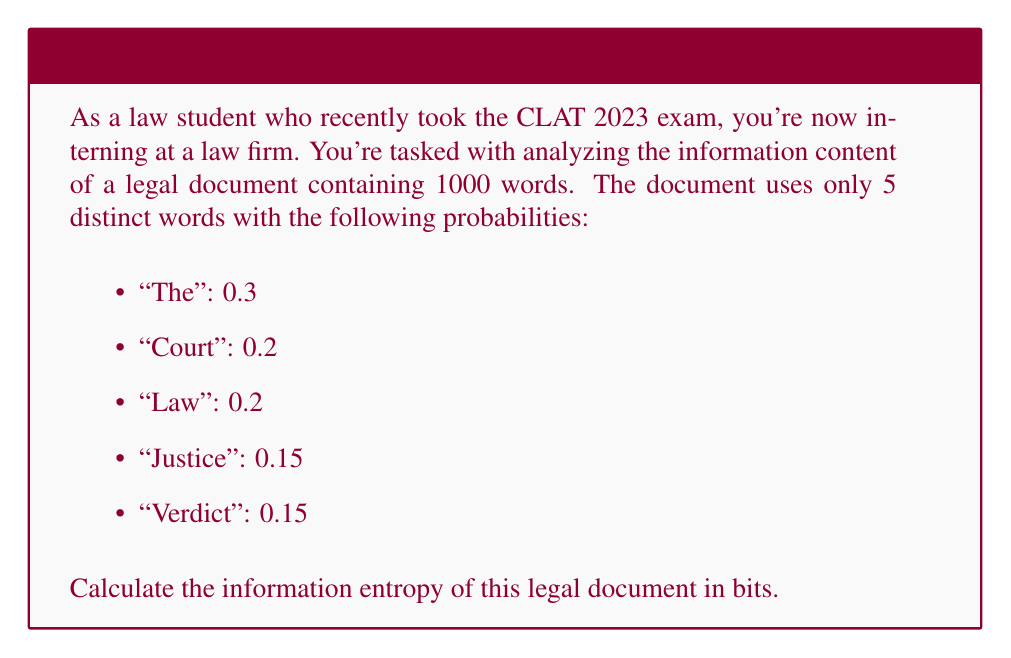Help me with this question. To solve this problem, we'll use the formula for information entropy:

$$ H = -\sum_{i=1}^n p_i \log_2(p_i) $$

Where:
- $H$ is the information entropy
- $p_i$ is the probability of each word
- $n$ is the number of distinct words

Let's calculate the entropy for each word:

1. "The": $-0.3 \log_2(0.3) = 0.521$ bits
2. "Court": $-0.2 \log_2(0.2) = 0.464$ bits
3. "Law": $-0.2 \log_2(0.2) = 0.464$ bits
4. "Justice": $-0.15 \log_2(0.15) = 0.411$ bits
5. "Verdict": $-0.15 \log_2(0.15) = 0.411$ bits

Now, we sum these values:

$$ H = 0.521 + 0.464 + 0.464 + 0.411 + 0.411 = 2.271 \text{ bits} $$

This result represents the average amount of information contained in each word of the document. To find the total information entropy of the entire 1000-word document, we multiply this value by 1000:

$$ H_{total} = 2.271 \times 1000 = 2271 \text{ bits} $$
Answer: The information entropy of the legal document is 2271 bits. 